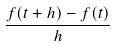Convert formula to latex. <formula><loc_0><loc_0><loc_500><loc_500>\frac { f ( t + h ) - f ( t ) } { h }</formula> 